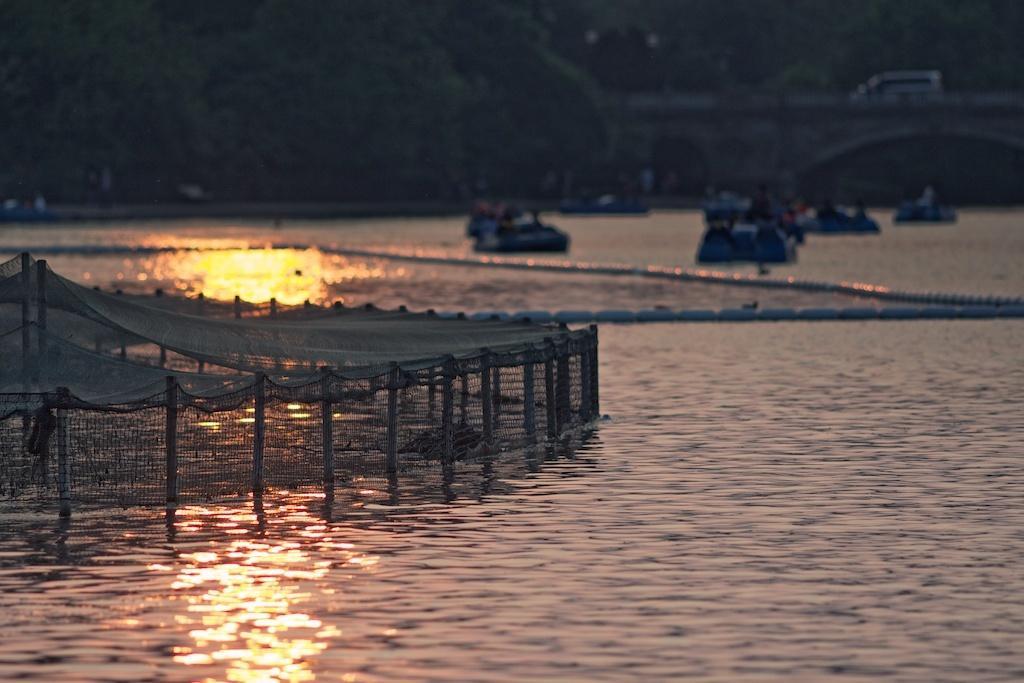Could you give a brief overview of what you see in this image? In this picture there is net on the left side of the image on the water and there are boats on the water and there is a car on the bridge at the top side of the image. 